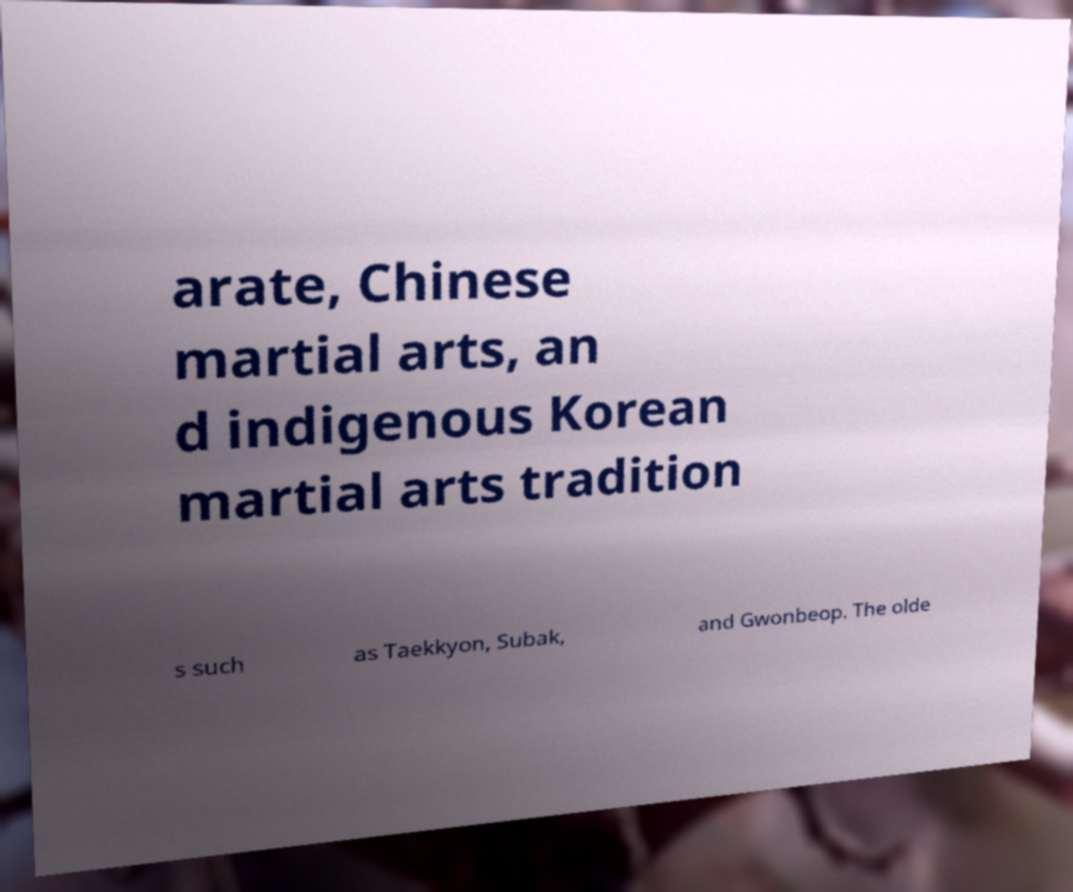There's text embedded in this image that I need extracted. Can you transcribe it verbatim? arate, Chinese martial arts, an d indigenous Korean martial arts tradition s such as Taekkyon, Subak, and Gwonbeop. The olde 